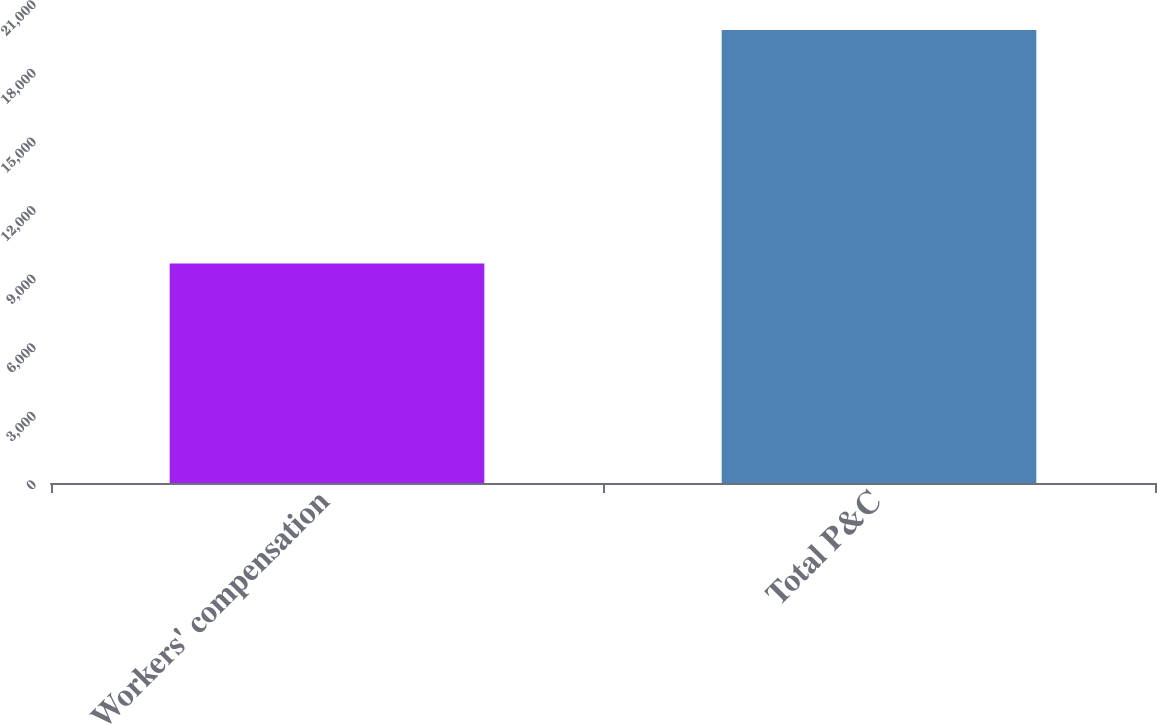Convert chart. <chart><loc_0><loc_0><loc_500><loc_500><bar_chart><fcel>Workers' compensation<fcel>Total P&C<nl><fcel>9600<fcel>19818<nl></chart> 